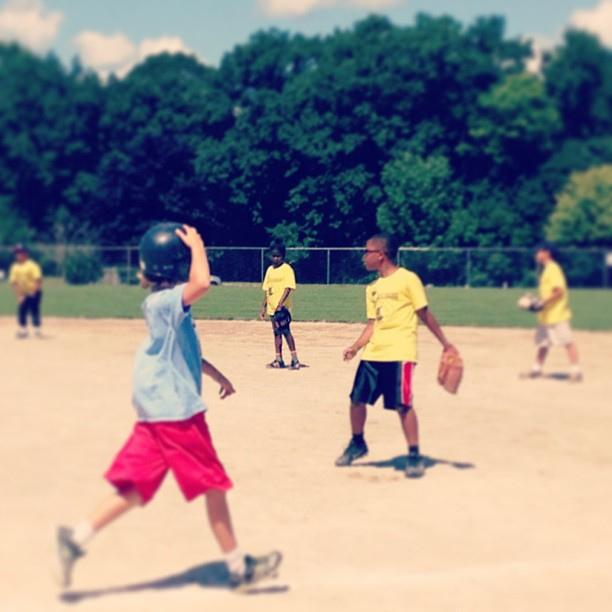What color are the shorts on the boy wearing a baseball helmet?

Choices:
A) black
B) yellow
C) red
D) blue red 